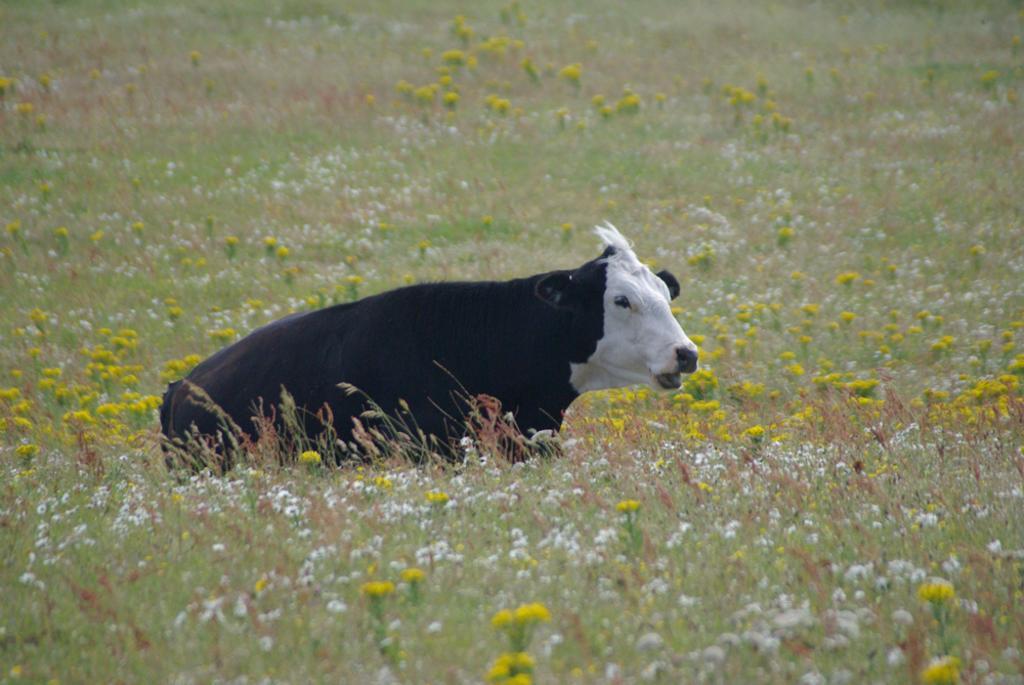Can you describe this image briefly? In the picture we can see a grass surface with some grass plants and flowers to it which are yellow in color and some are white in color and on it we can see a cow sitting which is black in color and to the face white in color. 